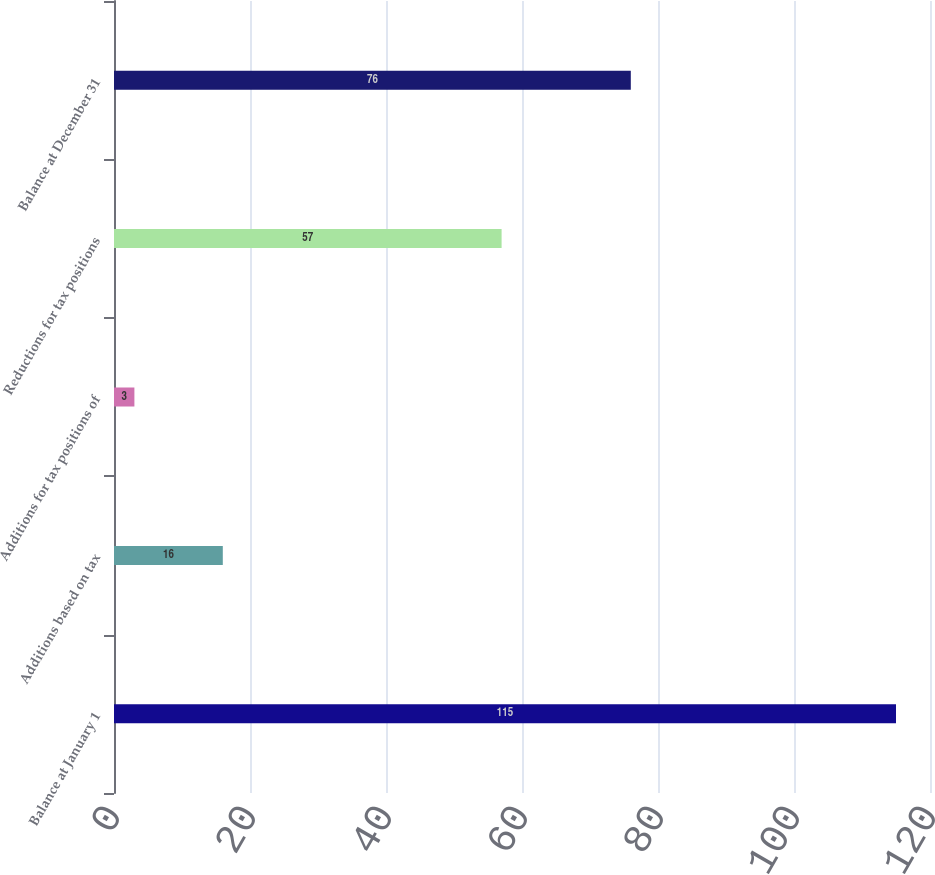<chart> <loc_0><loc_0><loc_500><loc_500><bar_chart><fcel>Balance at January 1<fcel>Additions based on tax<fcel>Additions for tax positions of<fcel>Reductions for tax positions<fcel>Balance at December 31<nl><fcel>115<fcel>16<fcel>3<fcel>57<fcel>76<nl></chart> 